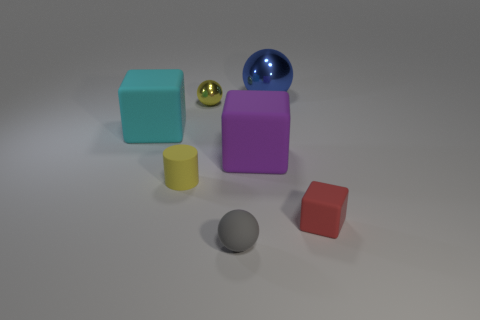Can you tell me what colors the objects in the image have? Certainly, there are multiple objects with various colors in this image: a teal blue cube, a yellow cylinder, a purple rectangular prism, a reflective blue sphere, a shiny gold sphere, a red cube, and a grey sphere. 